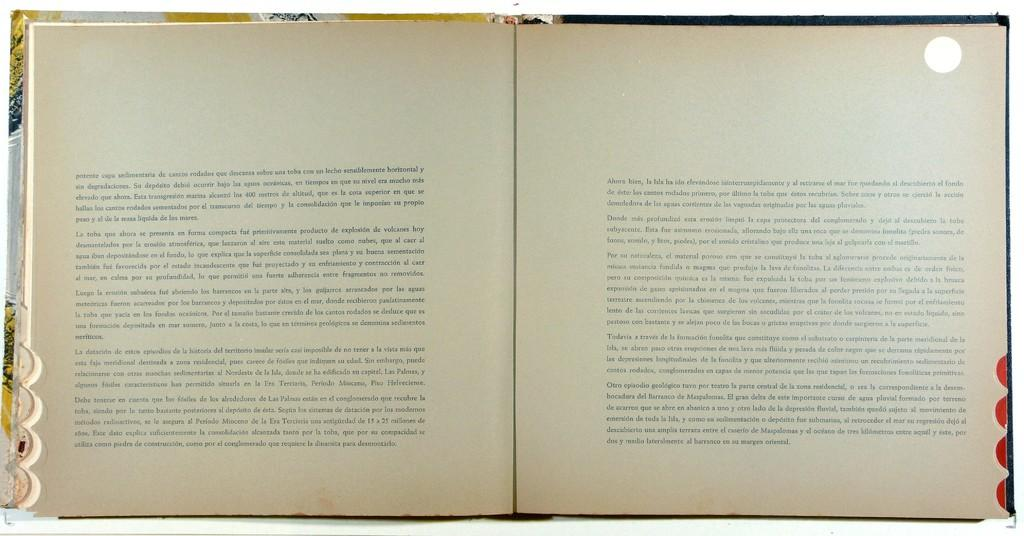What object can be seen in the image? There is a book in the image. What is the state of the book in the image? The book is opened. What can be seen inside the book? The script is visible in the book. How many dolls are sitting on the book in the image? There are no dolls present in the image; it features a book with visible script. What language is the script written in the book? The provided facts do not specify the language of the script in the book. 